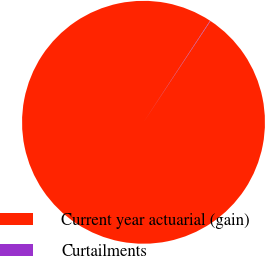Convert chart to OTSL. <chart><loc_0><loc_0><loc_500><loc_500><pie_chart><fcel>Current year actuarial (gain)<fcel>Curtailments<nl><fcel>99.95%<fcel>0.05%<nl></chart> 